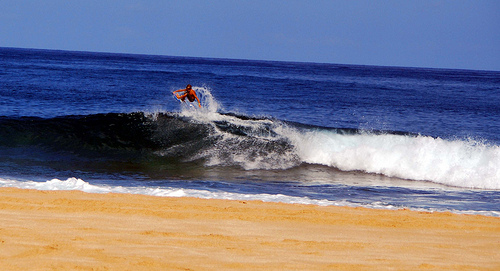Please provide the bounding box coordinate of the region this sentence describes: a man surfing the wave. For an encompassing view of a man's dynamic interaction with the ocean wave through surfing, the bounding box expands to [0.15, 0.28, 0.78, 0.68], framing the full extension of the surfboard and the spray of water. 